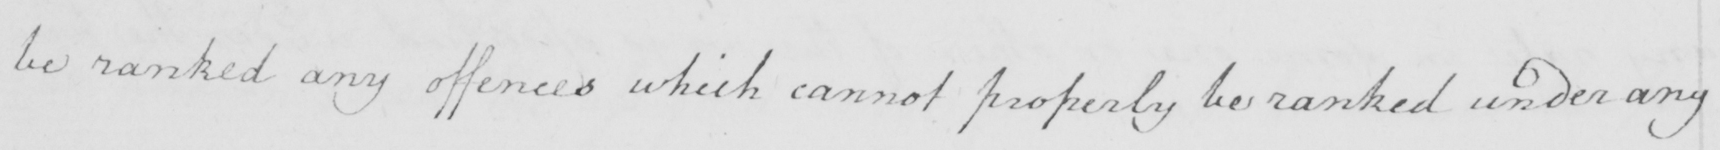What is written in this line of handwriting? be ranked any offences which cannot properly be ranked under any 